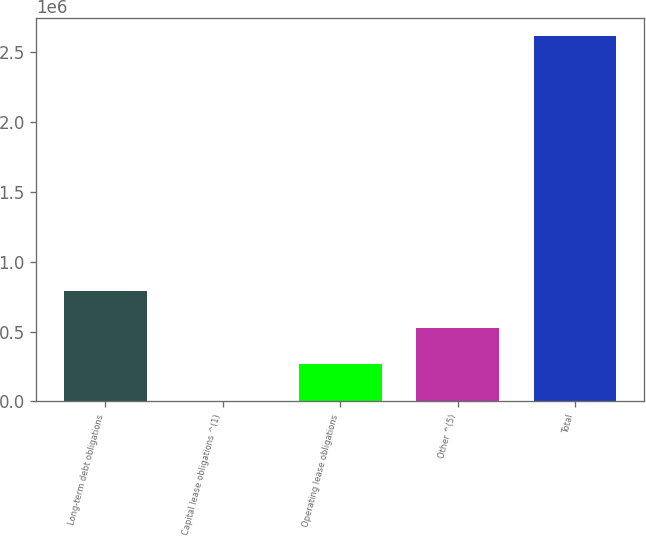Convert chart to OTSL. <chart><loc_0><loc_0><loc_500><loc_500><bar_chart><fcel>Long-term debt obligations<fcel>Capital lease obligations ^(1)<fcel>Operating lease obligations<fcel>Other ^(5)<fcel>Total<nl><fcel>786429<fcel>4920<fcel>265423<fcel>525926<fcel>2.60995e+06<nl></chart> 